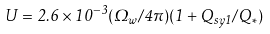Convert formula to latex. <formula><loc_0><loc_0><loc_500><loc_500>U = 2 . 6 \times 1 0 ^ { - 3 } ( \Omega _ { w } / 4 \pi ) ( 1 + Q _ { s y 1 } / Q _ { * } )</formula> 